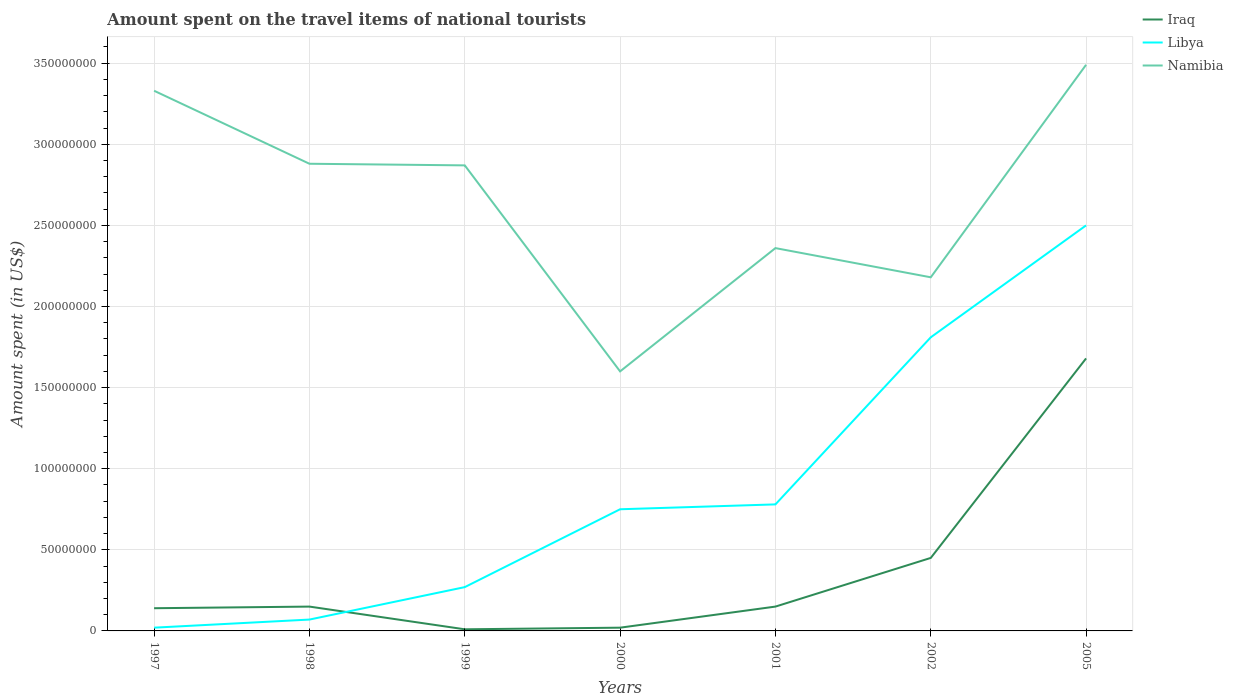Does the line corresponding to Libya intersect with the line corresponding to Iraq?
Offer a terse response. Yes. Is the number of lines equal to the number of legend labels?
Your answer should be very brief. Yes. Across all years, what is the maximum amount spent on the travel items of national tourists in Iraq?
Provide a short and direct response. 1.00e+06. What is the total amount spent on the travel items of national tourists in Namibia in the graph?
Make the answer very short. 4.60e+07. What is the difference between the highest and the second highest amount spent on the travel items of national tourists in Libya?
Your response must be concise. 2.48e+08. What is the difference between the highest and the lowest amount spent on the travel items of national tourists in Libya?
Offer a very short reply. 2. How many years are there in the graph?
Offer a very short reply. 7. What is the difference between two consecutive major ticks on the Y-axis?
Ensure brevity in your answer.  5.00e+07. Are the values on the major ticks of Y-axis written in scientific E-notation?
Provide a succinct answer. No. Does the graph contain any zero values?
Provide a succinct answer. No. Where does the legend appear in the graph?
Give a very brief answer. Top right. How many legend labels are there?
Your answer should be very brief. 3. What is the title of the graph?
Provide a short and direct response. Amount spent on the travel items of national tourists. Does "Ecuador" appear as one of the legend labels in the graph?
Provide a short and direct response. No. What is the label or title of the Y-axis?
Make the answer very short. Amount spent (in US$). What is the Amount spent (in US$) in Iraq in 1997?
Your response must be concise. 1.40e+07. What is the Amount spent (in US$) in Libya in 1997?
Keep it short and to the point. 2.00e+06. What is the Amount spent (in US$) in Namibia in 1997?
Ensure brevity in your answer.  3.33e+08. What is the Amount spent (in US$) in Iraq in 1998?
Provide a succinct answer. 1.50e+07. What is the Amount spent (in US$) in Namibia in 1998?
Keep it short and to the point. 2.88e+08. What is the Amount spent (in US$) in Iraq in 1999?
Your answer should be very brief. 1.00e+06. What is the Amount spent (in US$) in Libya in 1999?
Make the answer very short. 2.70e+07. What is the Amount spent (in US$) of Namibia in 1999?
Your answer should be compact. 2.87e+08. What is the Amount spent (in US$) of Iraq in 2000?
Keep it short and to the point. 2.00e+06. What is the Amount spent (in US$) of Libya in 2000?
Offer a terse response. 7.50e+07. What is the Amount spent (in US$) of Namibia in 2000?
Your answer should be compact. 1.60e+08. What is the Amount spent (in US$) in Iraq in 2001?
Your answer should be compact. 1.50e+07. What is the Amount spent (in US$) of Libya in 2001?
Your answer should be very brief. 7.80e+07. What is the Amount spent (in US$) of Namibia in 2001?
Your answer should be compact. 2.36e+08. What is the Amount spent (in US$) of Iraq in 2002?
Provide a short and direct response. 4.50e+07. What is the Amount spent (in US$) in Libya in 2002?
Your answer should be compact. 1.81e+08. What is the Amount spent (in US$) of Namibia in 2002?
Provide a short and direct response. 2.18e+08. What is the Amount spent (in US$) of Iraq in 2005?
Keep it short and to the point. 1.68e+08. What is the Amount spent (in US$) of Libya in 2005?
Offer a terse response. 2.50e+08. What is the Amount spent (in US$) of Namibia in 2005?
Provide a short and direct response. 3.49e+08. Across all years, what is the maximum Amount spent (in US$) in Iraq?
Offer a terse response. 1.68e+08. Across all years, what is the maximum Amount spent (in US$) of Libya?
Give a very brief answer. 2.50e+08. Across all years, what is the maximum Amount spent (in US$) of Namibia?
Ensure brevity in your answer.  3.49e+08. Across all years, what is the minimum Amount spent (in US$) in Libya?
Give a very brief answer. 2.00e+06. Across all years, what is the minimum Amount spent (in US$) in Namibia?
Make the answer very short. 1.60e+08. What is the total Amount spent (in US$) of Iraq in the graph?
Ensure brevity in your answer.  2.60e+08. What is the total Amount spent (in US$) in Libya in the graph?
Offer a very short reply. 6.20e+08. What is the total Amount spent (in US$) in Namibia in the graph?
Make the answer very short. 1.87e+09. What is the difference between the Amount spent (in US$) in Iraq in 1997 and that in 1998?
Make the answer very short. -1.00e+06. What is the difference between the Amount spent (in US$) of Libya in 1997 and that in 1998?
Offer a very short reply. -5.00e+06. What is the difference between the Amount spent (in US$) in Namibia in 1997 and that in 1998?
Your response must be concise. 4.50e+07. What is the difference between the Amount spent (in US$) of Iraq in 1997 and that in 1999?
Your response must be concise. 1.30e+07. What is the difference between the Amount spent (in US$) of Libya in 1997 and that in 1999?
Your answer should be very brief. -2.50e+07. What is the difference between the Amount spent (in US$) of Namibia in 1997 and that in 1999?
Make the answer very short. 4.60e+07. What is the difference between the Amount spent (in US$) in Iraq in 1997 and that in 2000?
Ensure brevity in your answer.  1.20e+07. What is the difference between the Amount spent (in US$) in Libya in 1997 and that in 2000?
Provide a short and direct response. -7.30e+07. What is the difference between the Amount spent (in US$) of Namibia in 1997 and that in 2000?
Ensure brevity in your answer.  1.73e+08. What is the difference between the Amount spent (in US$) in Iraq in 1997 and that in 2001?
Make the answer very short. -1.00e+06. What is the difference between the Amount spent (in US$) in Libya in 1997 and that in 2001?
Make the answer very short. -7.60e+07. What is the difference between the Amount spent (in US$) of Namibia in 1997 and that in 2001?
Offer a very short reply. 9.70e+07. What is the difference between the Amount spent (in US$) of Iraq in 1997 and that in 2002?
Keep it short and to the point. -3.10e+07. What is the difference between the Amount spent (in US$) of Libya in 1997 and that in 2002?
Make the answer very short. -1.79e+08. What is the difference between the Amount spent (in US$) in Namibia in 1997 and that in 2002?
Your answer should be very brief. 1.15e+08. What is the difference between the Amount spent (in US$) in Iraq in 1997 and that in 2005?
Give a very brief answer. -1.54e+08. What is the difference between the Amount spent (in US$) of Libya in 1997 and that in 2005?
Provide a succinct answer. -2.48e+08. What is the difference between the Amount spent (in US$) in Namibia in 1997 and that in 2005?
Provide a succinct answer. -1.60e+07. What is the difference between the Amount spent (in US$) in Iraq in 1998 and that in 1999?
Give a very brief answer. 1.40e+07. What is the difference between the Amount spent (in US$) in Libya in 1998 and that in 1999?
Keep it short and to the point. -2.00e+07. What is the difference between the Amount spent (in US$) in Namibia in 1998 and that in 1999?
Ensure brevity in your answer.  1.00e+06. What is the difference between the Amount spent (in US$) of Iraq in 1998 and that in 2000?
Provide a short and direct response. 1.30e+07. What is the difference between the Amount spent (in US$) of Libya in 1998 and that in 2000?
Provide a short and direct response. -6.80e+07. What is the difference between the Amount spent (in US$) in Namibia in 1998 and that in 2000?
Your answer should be very brief. 1.28e+08. What is the difference between the Amount spent (in US$) of Iraq in 1998 and that in 2001?
Give a very brief answer. 0. What is the difference between the Amount spent (in US$) of Libya in 1998 and that in 2001?
Your response must be concise. -7.10e+07. What is the difference between the Amount spent (in US$) in Namibia in 1998 and that in 2001?
Your answer should be compact. 5.20e+07. What is the difference between the Amount spent (in US$) in Iraq in 1998 and that in 2002?
Your answer should be compact. -3.00e+07. What is the difference between the Amount spent (in US$) of Libya in 1998 and that in 2002?
Give a very brief answer. -1.74e+08. What is the difference between the Amount spent (in US$) of Namibia in 1998 and that in 2002?
Your response must be concise. 7.00e+07. What is the difference between the Amount spent (in US$) of Iraq in 1998 and that in 2005?
Your response must be concise. -1.53e+08. What is the difference between the Amount spent (in US$) in Libya in 1998 and that in 2005?
Your answer should be very brief. -2.43e+08. What is the difference between the Amount spent (in US$) in Namibia in 1998 and that in 2005?
Provide a succinct answer. -6.10e+07. What is the difference between the Amount spent (in US$) in Libya in 1999 and that in 2000?
Your answer should be compact. -4.80e+07. What is the difference between the Amount spent (in US$) of Namibia in 1999 and that in 2000?
Offer a very short reply. 1.27e+08. What is the difference between the Amount spent (in US$) of Iraq in 1999 and that in 2001?
Offer a terse response. -1.40e+07. What is the difference between the Amount spent (in US$) in Libya in 1999 and that in 2001?
Your answer should be very brief. -5.10e+07. What is the difference between the Amount spent (in US$) of Namibia in 1999 and that in 2001?
Provide a succinct answer. 5.10e+07. What is the difference between the Amount spent (in US$) of Iraq in 1999 and that in 2002?
Your answer should be very brief. -4.40e+07. What is the difference between the Amount spent (in US$) in Libya in 1999 and that in 2002?
Provide a succinct answer. -1.54e+08. What is the difference between the Amount spent (in US$) of Namibia in 1999 and that in 2002?
Offer a terse response. 6.90e+07. What is the difference between the Amount spent (in US$) in Iraq in 1999 and that in 2005?
Provide a succinct answer. -1.67e+08. What is the difference between the Amount spent (in US$) of Libya in 1999 and that in 2005?
Keep it short and to the point. -2.23e+08. What is the difference between the Amount spent (in US$) of Namibia in 1999 and that in 2005?
Give a very brief answer. -6.20e+07. What is the difference between the Amount spent (in US$) of Iraq in 2000 and that in 2001?
Your response must be concise. -1.30e+07. What is the difference between the Amount spent (in US$) in Namibia in 2000 and that in 2001?
Give a very brief answer. -7.60e+07. What is the difference between the Amount spent (in US$) of Iraq in 2000 and that in 2002?
Give a very brief answer. -4.30e+07. What is the difference between the Amount spent (in US$) in Libya in 2000 and that in 2002?
Your response must be concise. -1.06e+08. What is the difference between the Amount spent (in US$) in Namibia in 2000 and that in 2002?
Ensure brevity in your answer.  -5.80e+07. What is the difference between the Amount spent (in US$) of Iraq in 2000 and that in 2005?
Your answer should be compact. -1.66e+08. What is the difference between the Amount spent (in US$) of Libya in 2000 and that in 2005?
Give a very brief answer. -1.75e+08. What is the difference between the Amount spent (in US$) of Namibia in 2000 and that in 2005?
Offer a terse response. -1.89e+08. What is the difference between the Amount spent (in US$) in Iraq in 2001 and that in 2002?
Your answer should be very brief. -3.00e+07. What is the difference between the Amount spent (in US$) of Libya in 2001 and that in 2002?
Ensure brevity in your answer.  -1.03e+08. What is the difference between the Amount spent (in US$) in Namibia in 2001 and that in 2002?
Your answer should be very brief. 1.80e+07. What is the difference between the Amount spent (in US$) of Iraq in 2001 and that in 2005?
Give a very brief answer. -1.53e+08. What is the difference between the Amount spent (in US$) of Libya in 2001 and that in 2005?
Provide a short and direct response. -1.72e+08. What is the difference between the Amount spent (in US$) in Namibia in 2001 and that in 2005?
Provide a short and direct response. -1.13e+08. What is the difference between the Amount spent (in US$) in Iraq in 2002 and that in 2005?
Provide a succinct answer. -1.23e+08. What is the difference between the Amount spent (in US$) of Libya in 2002 and that in 2005?
Your answer should be compact. -6.90e+07. What is the difference between the Amount spent (in US$) in Namibia in 2002 and that in 2005?
Your answer should be compact. -1.31e+08. What is the difference between the Amount spent (in US$) of Iraq in 1997 and the Amount spent (in US$) of Libya in 1998?
Your answer should be very brief. 7.00e+06. What is the difference between the Amount spent (in US$) of Iraq in 1997 and the Amount spent (in US$) of Namibia in 1998?
Make the answer very short. -2.74e+08. What is the difference between the Amount spent (in US$) in Libya in 1997 and the Amount spent (in US$) in Namibia in 1998?
Keep it short and to the point. -2.86e+08. What is the difference between the Amount spent (in US$) of Iraq in 1997 and the Amount spent (in US$) of Libya in 1999?
Give a very brief answer. -1.30e+07. What is the difference between the Amount spent (in US$) in Iraq in 1997 and the Amount spent (in US$) in Namibia in 1999?
Give a very brief answer. -2.73e+08. What is the difference between the Amount spent (in US$) in Libya in 1997 and the Amount spent (in US$) in Namibia in 1999?
Make the answer very short. -2.85e+08. What is the difference between the Amount spent (in US$) of Iraq in 1997 and the Amount spent (in US$) of Libya in 2000?
Provide a short and direct response. -6.10e+07. What is the difference between the Amount spent (in US$) of Iraq in 1997 and the Amount spent (in US$) of Namibia in 2000?
Ensure brevity in your answer.  -1.46e+08. What is the difference between the Amount spent (in US$) in Libya in 1997 and the Amount spent (in US$) in Namibia in 2000?
Make the answer very short. -1.58e+08. What is the difference between the Amount spent (in US$) in Iraq in 1997 and the Amount spent (in US$) in Libya in 2001?
Give a very brief answer. -6.40e+07. What is the difference between the Amount spent (in US$) in Iraq in 1997 and the Amount spent (in US$) in Namibia in 2001?
Offer a terse response. -2.22e+08. What is the difference between the Amount spent (in US$) in Libya in 1997 and the Amount spent (in US$) in Namibia in 2001?
Provide a succinct answer. -2.34e+08. What is the difference between the Amount spent (in US$) of Iraq in 1997 and the Amount spent (in US$) of Libya in 2002?
Offer a very short reply. -1.67e+08. What is the difference between the Amount spent (in US$) of Iraq in 1997 and the Amount spent (in US$) of Namibia in 2002?
Provide a succinct answer. -2.04e+08. What is the difference between the Amount spent (in US$) in Libya in 1997 and the Amount spent (in US$) in Namibia in 2002?
Give a very brief answer. -2.16e+08. What is the difference between the Amount spent (in US$) of Iraq in 1997 and the Amount spent (in US$) of Libya in 2005?
Make the answer very short. -2.36e+08. What is the difference between the Amount spent (in US$) of Iraq in 1997 and the Amount spent (in US$) of Namibia in 2005?
Your response must be concise. -3.35e+08. What is the difference between the Amount spent (in US$) of Libya in 1997 and the Amount spent (in US$) of Namibia in 2005?
Give a very brief answer. -3.47e+08. What is the difference between the Amount spent (in US$) in Iraq in 1998 and the Amount spent (in US$) in Libya in 1999?
Offer a very short reply. -1.20e+07. What is the difference between the Amount spent (in US$) of Iraq in 1998 and the Amount spent (in US$) of Namibia in 1999?
Your answer should be very brief. -2.72e+08. What is the difference between the Amount spent (in US$) of Libya in 1998 and the Amount spent (in US$) of Namibia in 1999?
Your answer should be very brief. -2.80e+08. What is the difference between the Amount spent (in US$) of Iraq in 1998 and the Amount spent (in US$) of Libya in 2000?
Provide a short and direct response. -6.00e+07. What is the difference between the Amount spent (in US$) in Iraq in 1998 and the Amount spent (in US$) in Namibia in 2000?
Your response must be concise. -1.45e+08. What is the difference between the Amount spent (in US$) of Libya in 1998 and the Amount spent (in US$) of Namibia in 2000?
Your response must be concise. -1.53e+08. What is the difference between the Amount spent (in US$) of Iraq in 1998 and the Amount spent (in US$) of Libya in 2001?
Ensure brevity in your answer.  -6.30e+07. What is the difference between the Amount spent (in US$) in Iraq in 1998 and the Amount spent (in US$) in Namibia in 2001?
Provide a succinct answer. -2.21e+08. What is the difference between the Amount spent (in US$) in Libya in 1998 and the Amount spent (in US$) in Namibia in 2001?
Offer a very short reply. -2.29e+08. What is the difference between the Amount spent (in US$) of Iraq in 1998 and the Amount spent (in US$) of Libya in 2002?
Give a very brief answer. -1.66e+08. What is the difference between the Amount spent (in US$) in Iraq in 1998 and the Amount spent (in US$) in Namibia in 2002?
Ensure brevity in your answer.  -2.03e+08. What is the difference between the Amount spent (in US$) in Libya in 1998 and the Amount spent (in US$) in Namibia in 2002?
Make the answer very short. -2.11e+08. What is the difference between the Amount spent (in US$) in Iraq in 1998 and the Amount spent (in US$) in Libya in 2005?
Provide a succinct answer. -2.35e+08. What is the difference between the Amount spent (in US$) of Iraq in 1998 and the Amount spent (in US$) of Namibia in 2005?
Provide a short and direct response. -3.34e+08. What is the difference between the Amount spent (in US$) in Libya in 1998 and the Amount spent (in US$) in Namibia in 2005?
Provide a succinct answer. -3.42e+08. What is the difference between the Amount spent (in US$) of Iraq in 1999 and the Amount spent (in US$) of Libya in 2000?
Provide a short and direct response. -7.40e+07. What is the difference between the Amount spent (in US$) of Iraq in 1999 and the Amount spent (in US$) of Namibia in 2000?
Make the answer very short. -1.59e+08. What is the difference between the Amount spent (in US$) of Libya in 1999 and the Amount spent (in US$) of Namibia in 2000?
Your answer should be very brief. -1.33e+08. What is the difference between the Amount spent (in US$) in Iraq in 1999 and the Amount spent (in US$) in Libya in 2001?
Your answer should be very brief. -7.70e+07. What is the difference between the Amount spent (in US$) in Iraq in 1999 and the Amount spent (in US$) in Namibia in 2001?
Ensure brevity in your answer.  -2.35e+08. What is the difference between the Amount spent (in US$) of Libya in 1999 and the Amount spent (in US$) of Namibia in 2001?
Your response must be concise. -2.09e+08. What is the difference between the Amount spent (in US$) in Iraq in 1999 and the Amount spent (in US$) in Libya in 2002?
Give a very brief answer. -1.80e+08. What is the difference between the Amount spent (in US$) in Iraq in 1999 and the Amount spent (in US$) in Namibia in 2002?
Offer a terse response. -2.17e+08. What is the difference between the Amount spent (in US$) in Libya in 1999 and the Amount spent (in US$) in Namibia in 2002?
Make the answer very short. -1.91e+08. What is the difference between the Amount spent (in US$) in Iraq in 1999 and the Amount spent (in US$) in Libya in 2005?
Provide a short and direct response. -2.49e+08. What is the difference between the Amount spent (in US$) of Iraq in 1999 and the Amount spent (in US$) of Namibia in 2005?
Ensure brevity in your answer.  -3.48e+08. What is the difference between the Amount spent (in US$) of Libya in 1999 and the Amount spent (in US$) of Namibia in 2005?
Make the answer very short. -3.22e+08. What is the difference between the Amount spent (in US$) of Iraq in 2000 and the Amount spent (in US$) of Libya in 2001?
Offer a terse response. -7.60e+07. What is the difference between the Amount spent (in US$) of Iraq in 2000 and the Amount spent (in US$) of Namibia in 2001?
Provide a succinct answer. -2.34e+08. What is the difference between the Amount spent (in US$) in Libya in 2000 and the Amount spent (in US$) in Namibia in 2001?
Your answer should be very brief. -1.61e+08. What is the difference between the Amount spent (in US$) in Iraq in 2000 and the Amount spent (in US$) in Libya in 2002?
Provide a short and direct response. -1.79e+08. What is the difference between the Amount spent (in US$) in Iraq in 2000 and the Amount spent (in US$) in Namibia in 2002?
Offer a very short reply. -2.16e+08. What is the difference between the Amount spent (in US$) in Libya in 2000 and the Amount spent (in US$) in Namibia in 2002?
Your response must be concise. -1.43e+08. What is the difference between the Amount spent (in US$) of Iraq in 2000 and the Amount spent (in US$) of Libya in 2005?
Provide a succinct answer. -2.48e+08. What is the difference between the Amount spent (in US$) in Iraq in 2000 and the Amount spent (in US$) in Namibia in 2005?
Give a very brief answer. -3.47e+08. What is the difference between the Amount spent (in US$) of Libya in 2000 and the Amount spent (in US$) of Namibia in 2005?
Keep it short and to the point. -2.74e+08. What is the difference between the Amount spent (in US$) of Iraq in 2001 and the Amount spent (in US$) of Libya in 2002?
Your answer should be very brief. -1.66e+08. What is the difference between the Amount spent (in US$) of Iraq in 2001 and the Amount spent (in US$) of Namibia in 2002?
Your answer should be compact. -2.03e+08. What is the difference between the Amount spent (in US$) of Libya in 2001 and the Amount spent (in US$) of Namibia in 2002?
Provide a succinct answer. -1.40e+08. What is the difference between the Amount spent (in US$) of Iraq in 2001 and the Amount spent (in US$) of Libya in 2005?
Make the answer very short. -2.35e+08. What is the difference between the Amount spent (in US$) of Iraq in 2001 and the Amount spent (in US$) of Namibia in 2005?
Keep it short and to the point. -3.34e+08. What is the difference between the Amount spent (in US$) in Libya in 2001 and the Amount spent (in US$) in Namibia in 2005?
Provide a short and direct response. -2.71e+08. What is the difference between the Amount spent (in US$) of Iraq in 2002 and the Amount spent (in US$) of Libya in 2005?
Your response must be concise. -2.05e+08. What is the difference between the Amount spent (in US$) of Iraq in 2002 and the Amount spent (in US$) of Namibia in 2005?
Make the answer very short. -3.04e+08. What is the difference between the Amount spent (in US$) of Libya in 2002 and the Amount spent (in US$) of Namibia in 2005?
Your answer should be compact. -1.68e+08. What is the average Amount spent (in US$) of Iraq per year?
Provide a succinct answer. 3.71e+07. What is the average Amount spent (in US$) of Libya per year?
Offer a very short reply. 8.86e+07. What is the average Amount spent (in US$) in Namibia per year?
Keep it short and to the point. 2.67e+08. In the year 1997, what is the difference between the Amount spent (in US$) of Iraq and Amount spent (in US$) of Libya?
Your answer should be very brief. 1.20e+07. In the year 1997, what is the difference between the Amount spent (in US$) of Iraq and Amount spent (in US$) of Namibia?
Your answer should be compact. -3.19e+08. In the year 1997, what is the difference between the Amount spent (in US$) in Libya and Amount spent (in US$) in Namibia?
Offer a terse response. -3.31e+08. In the year 1998, what is the difference between the Amount spent (in US$) of Iraq and Amount spent (in US$) of Namibia?
Make the answer very short. -2.73e+08. In the year 1998, what is the difference between the Amount spent (in US$) of Libya and Amount spent (in US$) of Namibia?
Offer a very short reply. -2.81e+08. In the year 1999, what is the difference between the Amount spent (in US$) in Iraq and Amount spent (in US$) in Libya?
Keep it short and to the point. -2.60e+07. In the year 1999, what is the difference between the Amount spent (in US$) in Iraq and Amount spent (in US$) in Namibia?
Keep it short and to the point. -2.86e+08. In the year 1999, what is the difference between the Amount spent (in US$) of Libya and Amount spent (in US$) of Namibia?
Your response must be concise. -2.60e+08. In the year 2000, what is the difference between the Amount spent (in US$) in Iraq and Amount spent (in US$) in Libya?
Provide a succinct answer. -7.30e+07. In the year 2000, what is the difference between the Amount spent (in US$) of Iraq and Amount spent (in US$) of Namibia?
Offer a terse response. -1.58e+08. In the year 2000, what is the difference between the Amount spent (in US$) in Libya and Amount spent (in US$) in Namibia?
Ensure brevity in your answer.  -8.50e+07. In the year 2001, what is the difference between the Amount spent (in US$) in Iraq and Amount spent (in US$) in Libya?
Your answer should be very brief. -6.30e+07. In the year 2001, what is the difference between the Amount spent (in US$) in Iraq and Amount spent (in US$) in Namibia?
Provide a short and direct response. -2.21e+08. In the year 2001, what is the difference between the Amount spent (in US$) in Libya and Amount spent (in US$) in Namibia?
Your answer should be compact. -1.58e+08. In the year 2002, what is the difference between the Amount spent (in US$) of Iraq and Amount spent (in US$) of Libya?
Your response must be concise. -1.36e+08. In the year 2002, what is the difference between the Amount spent (in US$) in Iraq and Amount spent (in US$) in Namibia?
Ensure brevity in your answer.  -1.73e+08. In the year 2002, what is the difference between the Amount spent (in US$) in Libya and Amount spent (in US$) in Namibia?
Offer a terse response. -3.70e+07. In the year 2005, what is the difference between the Amount spent (in US$) of Iraq and Amount spent (in US$) of Libya?
Provide a succinct answer. -8.20e+07. In the year 2005, what is the difference between the Amount spent (in US$) in Iraq and Amount spent (in US$) in Namibia?
Give a very brief answer. -1.81e+08. In the year 2005, what is the difference between the Amount spent (in US$) of Libya and Amount spent (in US$) of Namibia?
Offer a very short reply. -9.90e+07. What is the ratio of the Amount spent (in US$) of Libya in 1997 to that in 1998?
Your response must be concise. 0.29. What is the ratio of the Amount spent (in US$) in Namibia in 1997 to that in 1998?
Provide a short and direct response. 1.16. What is the ratio of the Amount spent (in US$) of Iraq in 1997 to that in 1999?
Provide a succinct answer. 14. What is the ratio of the Amount spent (in US$) in Libya in 1997 to that in 1999?
Provide a succinct answer. 0.07. What is the ratio of the Amount spent (in US$) in Namibia in 1997 to that in 1999?
Your answer should be very brief. 1.16. What is the ratio of the Amount spent (in US$) in Libya in 1997 to that in 2000?
Provide a short and direct response. 0.03. What is the ratio of the Amount spent (in US$) of Namibia in 1997 to that in 2000?
Keep it short and to the point. 2.08. What is the ratio of the Amount spent (in US$) of Iraq in 1997 to that in 2001?
Your response must be concise. 0.93. What is the ratio of the Amount spent (in US$) of Libya in 1997 to that in 2001?
Offer a very short reply. 0.03. What is the ratio of the Amount spent (in US$) in Namibia in 1997 to that in 2001?
Ensure brevity in your answer.  1.41. What is the ratio of the Amount spent (in US$) of Iraq in 1997 to that in 2002?
Offer a terse response. 0.31. What is the ratio of the Amount spent (in US$) of Libya in 1997 to that in 2002?
Offer a terse response. 0.01. What is the ratio of the Amount spent (in US$) of Namibia in 1997 to that in 2002?
Ensure brevity in your answer.  1.53. What is the ratio of the Amount spent (in US$) of Iraq in 1997 to that in 2005?
Ensure brevity in your answer.  0.08. What is the ratio of the Amount spent (in US$) in Libya in 1997 to that in 2005?
Provide a succinct answer. 0.01. What is the ratio of the Amount spent (in US$) in Namibia in 1997 to that in 2005?
Provide a succinct answer. 0.95. What is the ratio of the Amount spent (in US$) in Iraq in 1998 to that in 1999?
Offer a terse response. 15. What is the ratio of the Amount spent (in US$) of Libya in 1998 to that in 1999?
Give a very brief answer. 0.26. What is the ratio of the Amount spent (in US$) of Iraq in 1998 to that in 2000?
Give a very brief answer. 7.5. What is the ratio of the Amount spent (in US$) of Libya in 1998 to that in 2000?
Provide a short and direct response. 0.09. What is the ratio of the Amount spent (in US$) in Iraq in 1998 to that in 2001?
Your answer should be very brief. 1. What is the ratio of the Amount spent (in US$) in Libya in 1998 to that in 2001?
Offer a very short reply. 0.09. What is the ratio of the Amount spent (in US$) in Namibia in 1998 to that in 2001?
Your response must be concise. 1.22. What is the ratio of the Amount spent (in US$) in Libya in 1998 to that in 2002?
Your answer should be very brief. 0.04. What is the ratio of the Amount spent (in US$) in Namibia in 1998 to that in 2002?
Offer a very short reply. 1.32. What is the ratio of the Amount spent (in US$) in Iraq in 1998 to that in 2005?
Offer a terse response. 0.09. What is the ratio of the Amount spent (in US$) in Libya in 1998 to that in 2005?
Offer a terse response. 0.03. What is the ratio of the Amount spent (in US$) in Namibia in 1998 to that in 2005?
Make the answer very short. 0.83. What is the ratio of the Amount spent (in US$) of Libya in 1999 to that in 2000?
Offer a terse response. 0.36. What is the ratio of the Amount spent (in US$) in Namibia in 1999 to that in 2000?
Your answer should be compact. 1.79. What is the ratio of the Amount spent (in US$) in Iraq in 1999 to that in 2001?
Give a very brief answer. 0.07. What is the ratio of the Amount spent (in US$) of Libya in 1999 to that in 2001?
Your answer should be very brief. 0.35. What is the ratio of the Amount spent (in US$) of Namibia in 1999 to that in 2001?
Provide a succinct answer. 1.22. What is the ratio of the Amount spent (in US$) in Iraq in 1999 to that in 2002?
Your answer should be very brief. 0.02. What is the ratio of the Amount spent (in US$) in Libya in 1999 to that in 2002?
Ensure brevity in your answer.  0.15. What is the ratio of the Amount spent (in US$) in Namibia in 1999 to that in 2002?
Provide a short and direct response. 1.32. What is the ratio of the Amount spent (in US$) of Iraq in 1999 to that in 2005?
Provide a succinct answer. 0.01. What is the ratio of the Amount spent (in US$) of Libya in 1999 to that in 2005?
Keep it short and to the point. 0.11. What is the ratio of the Amount spent (in US$) in Namibia in 1999 to that in 2005?
Your response must be concise. 0.82. What is the ratio of the Amount spent (in US$) in Iraq in 2000 to that in 2001?
Ensure brevity in your answer.  0.13. What is the ratio of the Amount spent (in US$) of Libya in 2000 to that in 2001?
Keep it short and to the point. 0.96. What is the ratio of the Amount spent (in US$) in Namibia in 2000 to that in 2001?
Provide a succinct answer. 0.68. What is the ratio of the Amount spent (in US$) in Iraq in 2000 to that in 2002?
Keep it short and to the point. 0.04. What is the ratio of the Amount spent (in US$) in Libya in 2000 to that in 2002?
Ensure brevity in your answer.  0.41. What is the ratio of the Amount spent (in US$) of Namibia in 2000 to that in 2002?
Your answer should be compact. 0.73. What is the ratio of the Amount spent (in US$) in Iraq in 2000 to that in 2005?
Keep it short and to the point. 0.01. What is the ratio of the Amount spent (in US$) of Libya in 2000 to that in 2005?
Offer a terse response. 0.3. What is the ratio of the Amount spent (in US$) in Namibia in 2000 to that in 2005?
Your answer should be compact. 0.46. What is the ratio of the Amount spent (in US$) in Iraq in 2001 to that in 2002?
Keep it short and to the point. 0.33. What is the ratio of the Amount spent (in US$) in Libya in 2001 to that in 2002?
Ensure brevity in your answer.  0.43. What is the ratio of the Amount spent (in US$) in Namibia in 2001 to that in 2002?
Offer a terse response. 1.08. What is the ratio of the Amount spent (in US$) in Iraq in 2001 to that in 2005?
Offer a very short reply. 0.09. What is the ratio of the Amount spent (in US$) of Libya in 2001 to that in 2005?
Provide a succinct answer. 0.31. What is the ratio of the Amount spent (in US$) in Namibia in 2001 to that in 2005?
Offer a very short reply. 0.68. What is the ratio of the Amount spent (in US$) of Iraq in 2002 to that in 2005?
Your response must be concise. 0.27. What is the ratio of the Amount spent (in US$) of Libya in 2002 to that in 2005?
Provide a short and direct response. 0.72. What is the ratio of the Amount spent (in US$) of Namibia in 2002 to that in 2005?
Provide a short and direct response. 0.62. What is the difference between the highest and the second highest Amount spent (in US$) of Iraq?
Your answer should be very brief. 1.23e+08. What is the difference between the highest and the second highest Amount spent (in US$) of Libya?
Give a very brief answer. 6.90e+07. What is the difference between the highest and the second highest Amount spent (in US$) in Namibia?
Make the answer very short. 1.60e+07. What is the difference between the highest and the lowest Amount spent (in US$) of Iraq?
Provide a short and direct response. 1.67e+08. What is the difference between the highest and the lowest Amount spent (in US$) in Libya?
Provide a succinct answer. 2.48e+08. What is the difference between the highest and the lowest Amount spent (in US$) in Namibia?
Make the answer very short. 1.89e+08. 